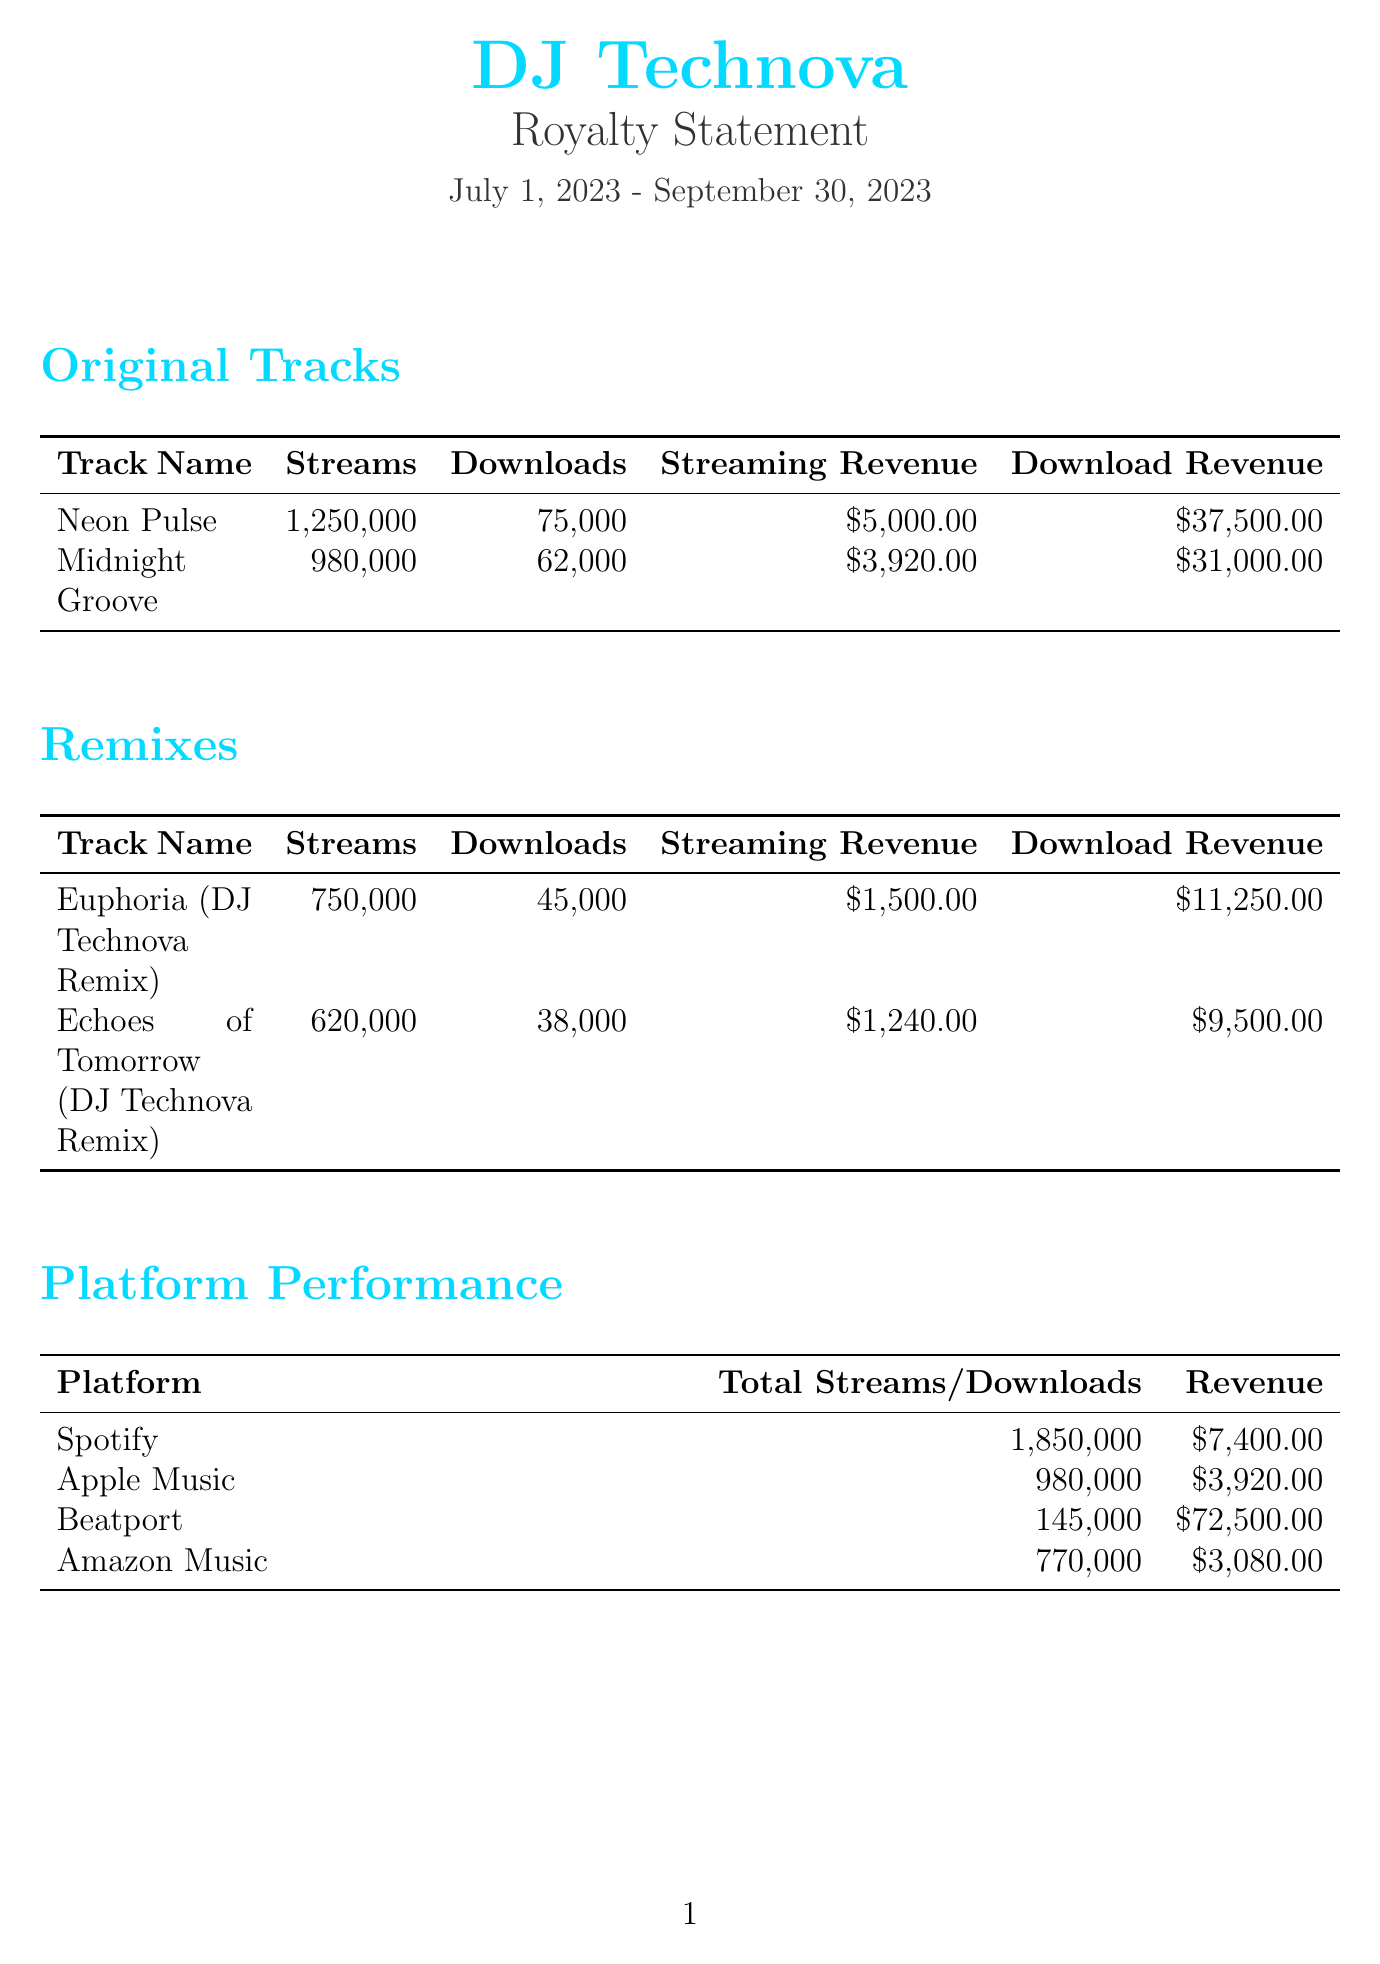What is the artist name? The artist name is the first element in the document, listed prominently at the top.
Answer: DJ Technova What is the label name? The label name appears after the artist name and is also featured prominently.
Answer: Beatport Records What is the statement period? The statement period indicates the time frame for the revenue reported and is stated clearly.
Answer: July 1, 2023 - September 30, 2023 How many streams did "Neon Pulse" receive? The streams for "Neon Pulse" is detailed under the Original Tracks section.
Answer: 1,250,000 What is the total revenue? The total revenue is summarized in the Financial Summary section of the document.
Answer: $100,890.00 How much is the label cut? The label cut is listed in the Financial Summary section.
Answer: $30,267.00 How much will the artist be paid? The artist payout is noted in the Financial Summary and reflects the total amount after the label cut.
Answer: $70,623.00 What is the release date for "Cyber Dreamscape"? The release date is provided in the Upcoming Releases section of the document.
Answer: November 15, 2023 What revenue percentage goes to the original artist for remixes? The notes section contains information on revenue splits for remixes.
Answer: 50% Which platform generated the highest revenue? The Platform Performance section shows revenue amounts by platform, indicating which one is highest.
Answer: Beatport 